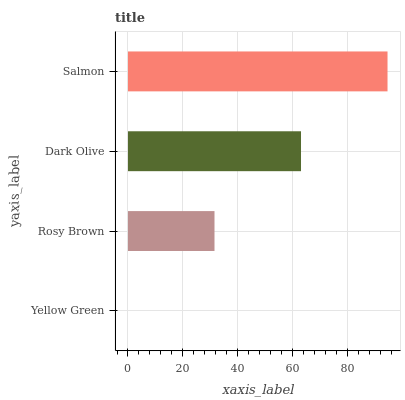Is Yellow Green the minimum?
Answer yes or no. Yes. Is Salmon the maximum?
Answer yes or no. Yes. Is Rosy Brown the minimum?
Answer yes or no. No. Is Rosy Brown the maximum?
Answer yes or no. No. Is Rosy Brown greater than Yellow Green?
Answer yes or no. Yes. Is Yellow Green less than Rosy Brown?
Answer yes or no. Yes. Is Yellow Green greater than Rosy Brown?
Answer yes or no. No. Is Rosy Brown less than Yellow Green?
Answer yes or no. No. Is Dark Olive the high median?
Answer yes or no. Yes. Is Rosy Brown the low median?
Answer yes or no. Yes. Is Yellow Green the high median?
Answer yes or no. No. Is Yellow Green the low median?
Answer yes or no. No. 